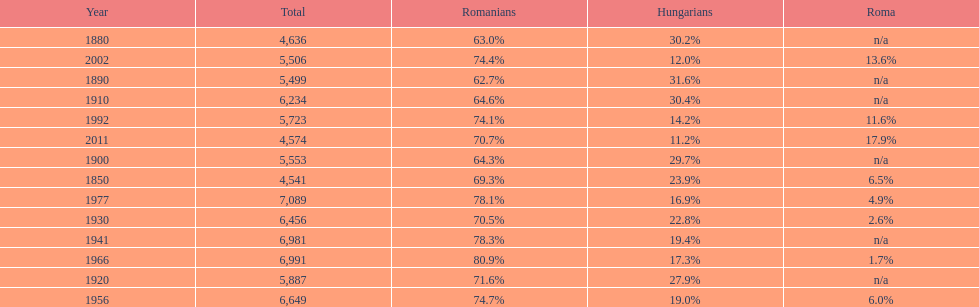1%, and what is the year prior to that? 1977. 